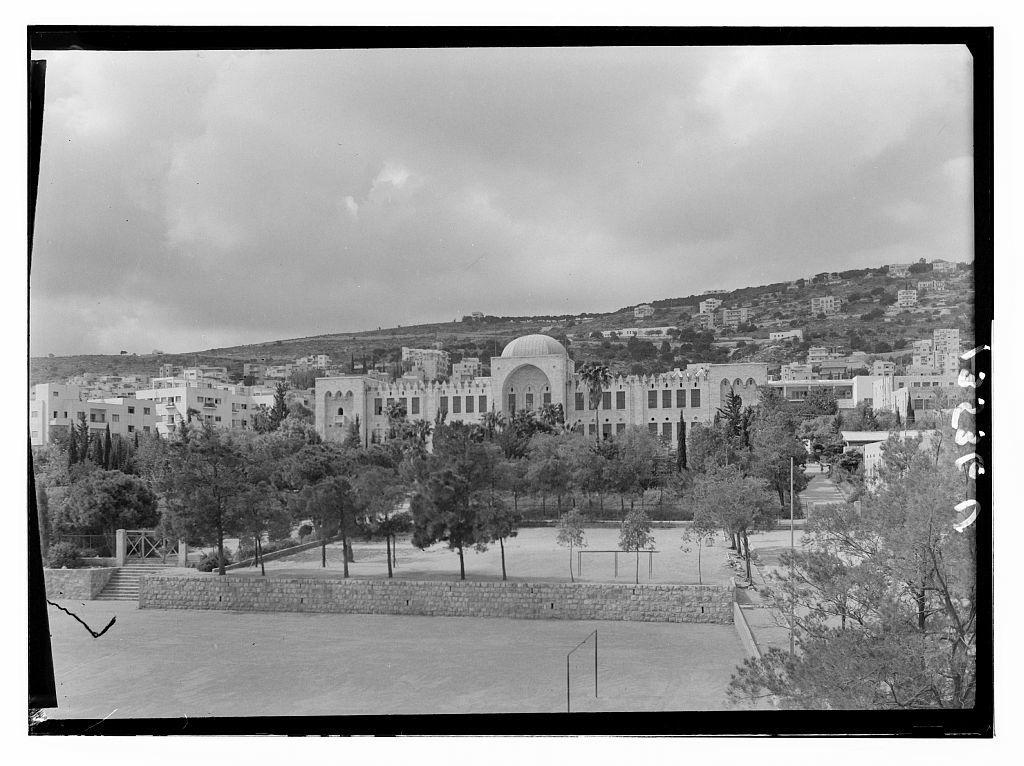What type of natural elements can be seen in the image? There are trees in the image. What type of man-made structures are present in the image? There are buildings in the image. What part of the natural environment is visible in the image? The sky is visible in the image. What architectural feature can be seen in the image? There are stairs in the image. What other objects can be seen in the image? There are poles in the image. How many beds are visible in the image? There are no beds present in the image. What type of spring can be seen in the image? There is no spring present in the image. 